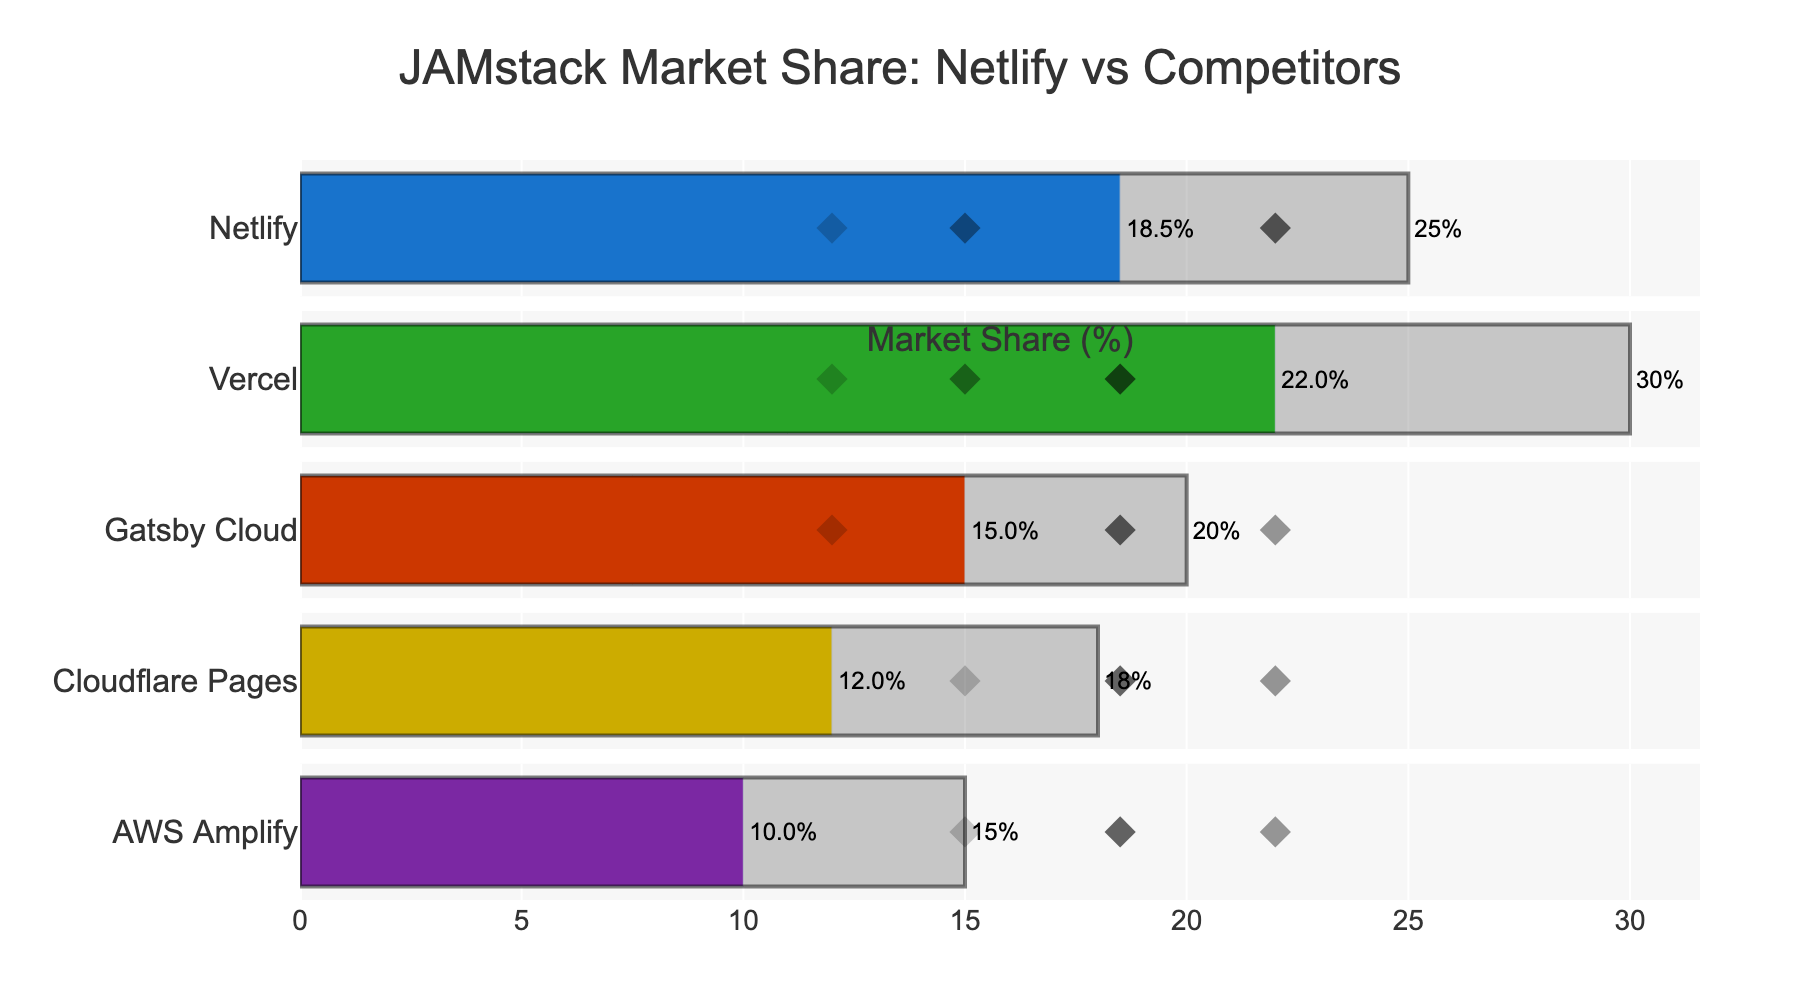What's the title of the chart? The title is located at the top center of the chart. It reads “JAMstack Market Share: Netlify vs Competitors”.
Answer: JAMstack Market Share: Netlify vs Competitors How many companies are analyzed in the chart? Each row in the chart represents a company. Count the separate rows to determine the total number of companies.
Answer: 5 What is Netlify's actual market share percentage? Find Netlify's row and locate the blue bar indicating the actual market share. The text on the blue bar shows the percentage.
Answer: 18.5% Which company has the highest target market share? Look for the largest grey bar among the target market share bars across all companies. The company associated with this bar has the highest target.
Answer: Vercel What's the overall trend in target market shares among the companies? Observe and compare the positions of the grey bars representing target market shares for all companies. Identify any common patterns, such as whether they generally exceed actual shares or show higher expectations.
Answer: Targets are higher than actuals for each company How much lower is Netlify's actual market share compared to its target? Find Netlify’s actual and target market share percentages, then subtract the actual from the target (25 - 18.5).
Answer: 6.5% Which competitor has the highest market share point plotted within Netlify's row? Within Netlify's row, identify the competitor mark (diamond symbol) with the highest value by comparing positions.
Answer: Competitor 1 (22%) Is AWS Amplify's actual market share higher or lower than the median value of Netlify's competitors? Find AWS Amplify's actual share and also the competitor points in Netlify’s row. Calculate the median of the competitor values (22, 15, 12) for comparison. As 18.5 is the median, compare it with Amplify’s 10.
Answer: Lower Which two companies have the closest actual market shares? Compare the lengths of the blue bars indicating actual market shares for all companies and identify the pair with minimum differences.
Answer: Cloudflare Pages and AWS Amplify Has any competitor of Netlify a market share worse than the least performing competitor based on Netlify's competitor markers? Note the lowest competitor market share in Netlify’s markers (which is 12%). Check other competitors, and whether any other company's competitor has a share below 12%.
Answer: No 